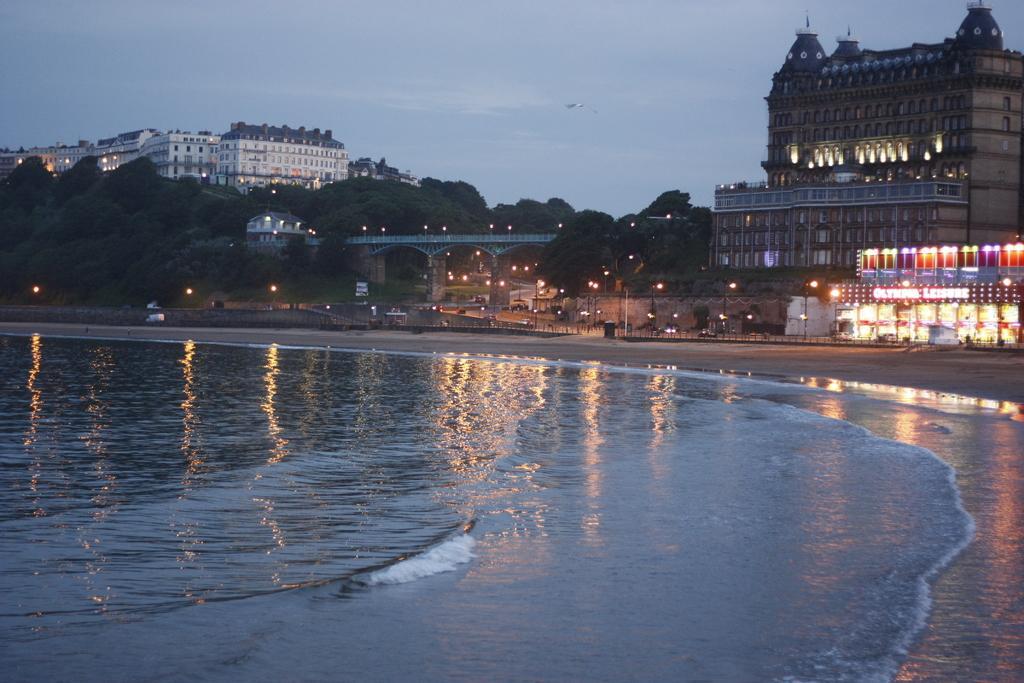How would you summarize this image in a sentence or two? In this image we can see some buildings, lights, bridge, trees and other objects. At the bottom of the image there is water. We can see some reflections on the water. At the top of the image there is the sky. 